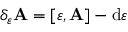<formula> <loc_0><loc_0><loc_500><loc_500>\delta _ { \varepsilon } A = [ \varepsilon , A ] - d \varepsilon</formula> 